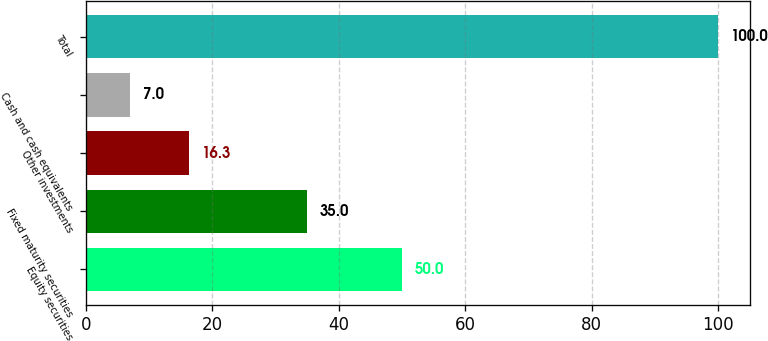<chart> <loc_0><loc_0><loc_500><loc_500><bar_chart><fcel>Equity securities<fcel>Fixed maturity securities<fcel>Other investments<fcel>Cash and cash equivalents<fcel>Total<nl><fcel>50<fcel>35<fcel>16.3<fcel>7<fcel>100<nl></chart> 